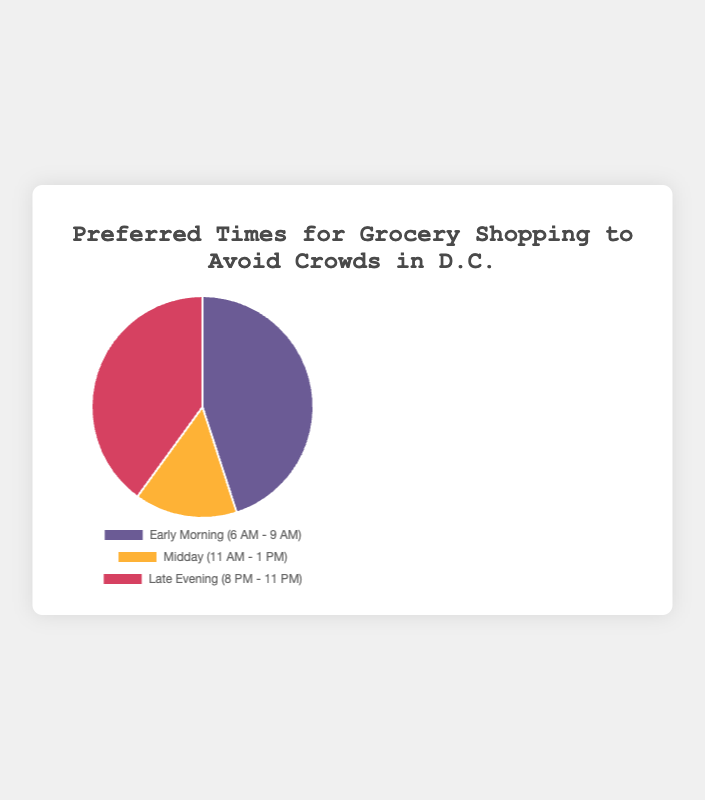Which time slot has the highest preference for grocery shopping to avoid crowds? Early Morning (6 AM - 9 AM) has the highest percentage at 45%.
Answer: Early Morning (6 AM - 9 AM) Which time slot has the lowest preference for grocery shopping to avoid crowds? Midday (11 AM - 1 PM) has the lowest percentage with 15%.
Answer: Midday (11 AM - 1 PM) What is the difference in percentage between the most and least preferred times for grocery shopping? The most preferred time is Early Morning (6 AM - 9 AM) with 45%, and the least preferred time is Midday (11 AM - 1 PM) with 15%. The difference is 45% - 15% = 30%.
Answer: 30% How much more popular is the Late Evening time slot compared to Midday? Late Evening (8 PM - 11 PM) is 40% and Midday (11 AM - 1 PM) is 15%. The difference is 40% - 15% = 25%.
Answer: 25% What is the combined percentage of people who prefer shopping either in the Early Morning or Late Evening? Early Morning has 45% and Late Evening has 40%. The combined percentage is 45% + 40% = 85%.
Answer: 85% What color represents the Late Evening time slot on this pie chart? The color representing the Late Evening time slot is a shade of red.
Answer: Red Compare the combined percentage of people who prefer shopping in the Early Morning and Midday vs. Late Evening. Which is higher? Early Morning (45%) + Midday (15%) = 60%, Late Evening is 40%. 60% is higher than 40%.
Answer: Combined Early Morning and Midday What fraction of people prefer to shop either in the Midday or Late Evening? Midday (11 AM - 1 PM) is 15% and Late Evening (8 PM - 11 PM) is 40%. The combined percentage is 15% + 40% = 55%. To convert this to a fraction, 55/100 = 11/20.
Answer: 11/20 